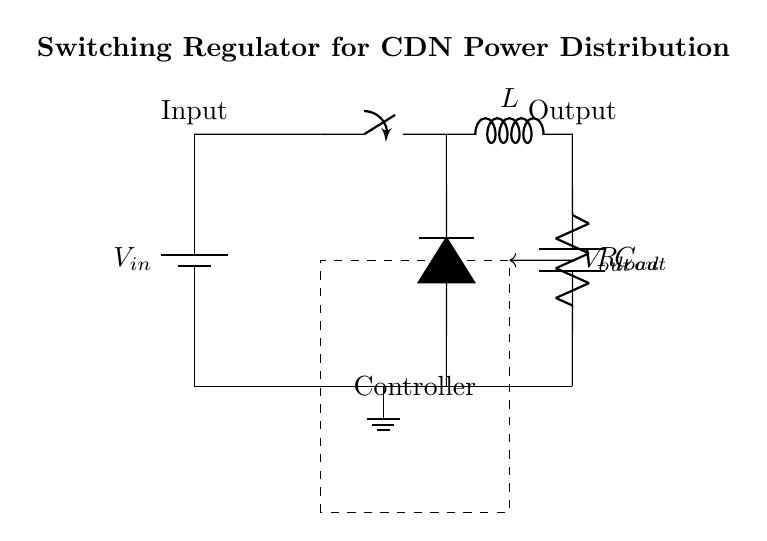What is the type of regulator shown in the circuit? The circuit diagram depicts a switching regulator, which is characterized by the presence of a switch and inductive components, used for efficiently converting and regulating voltage.
Answer: Switching regulator What is the role of the inductor in this circuit? The inductor in the circuit is used to store energy and release it to the load when the switch is off, helping to smooth out the current and regulate the output voltage.
Answer: Energy storage What is the purpose of the diode in the switching regulator? The diode is used to allow current to flow in one direction, ensuring that when the switch is off, the energy stored in the inductor can be delivered to the load without reversing current flow.
Answer: Current flow direction How many components are connected to the output node? There are two components connected: one is the output capacitor and the other is the load resistor, which together help stabilize the output voltage.
Answer: Two components What does the feedback loop in the circuit indicate? The feedback loop indicates that the output voltage is being monitored and compared to a reference voltage to control the switch operation, ensuring stable output voltage regulation.
Answer: Controlling switch operation What is the label of the component represented by "C" in the circuit? The component labeled "C" is the output capacitor, which is utilized to filter the output and provide stable operation by smoothing any voltage fluctuations.
Answer: Output capacitor What kind of input voltage is assumed for this regulator? The circuit assumes a DC input voltage, typically referred to as "V_in", which is necessary for the switching regulator operation.
Answer: DC input voltage 